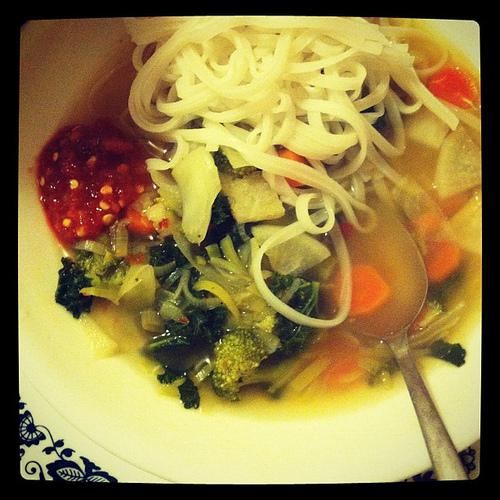Question: what food is it?
Choices:
A. Hot dog's.
B. Pasta.
C. Soup.
D. Rice.
Answer with the letter. Answer: C Question: what is in the bowl?
Choices:
A. Flowers.
B. Water.
C. Fish.
D. Food.
Answer with the letter. Answer: D Question: who will eat?
Choices:
A. A person.
B. Dog.
C. Deer.
D. Sharks.
Answer with the letter. Answer: A 